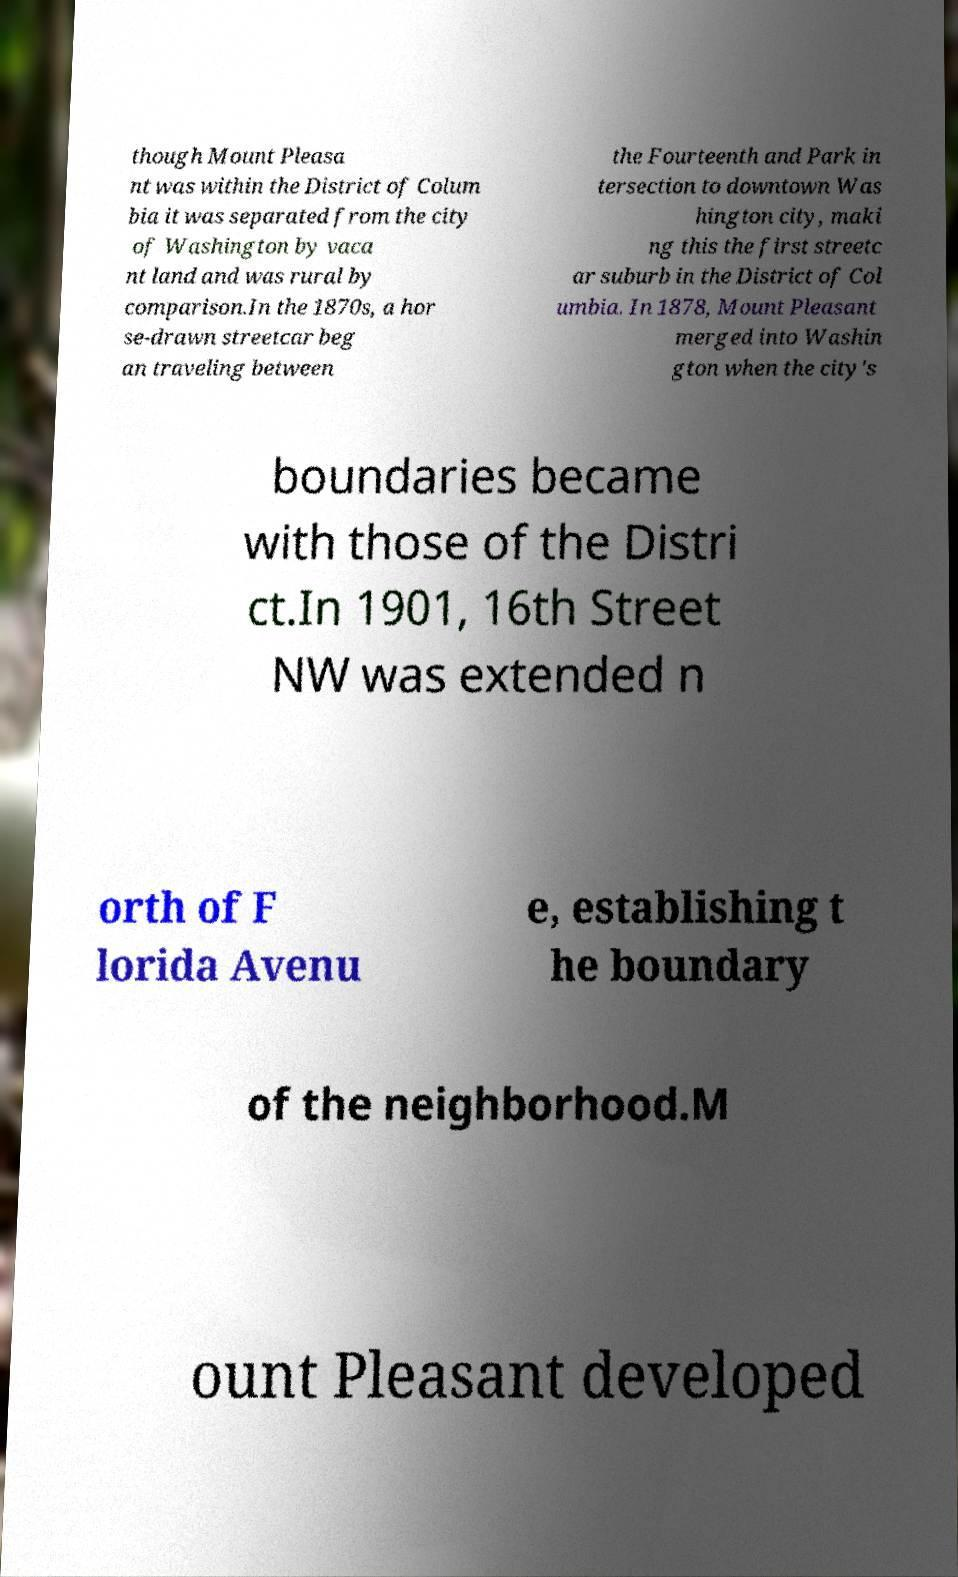Could you assist in decoding the text presented in this image and type it out clearly? though Mount Pleasa nt was within the District of Colum bia it was separated from the city of Washington by vaca nt land and was rural by comparison.In the 1870s, a hor se-drawn streetcar beg an traveling between the Fourteenth and Park in tersection to downtown Was hington city, maki ng this the first streetc ar suburb in the District of Col umbia. In 1878, Mount Pleasant merged into Washin gton when the city's boundaries became with those of the Distri ct.In 1901, 16th Street NW was extended n orth of F lorida Avenu e, establishing t he boundary of the neighborhood.M ount Pleasant developed 